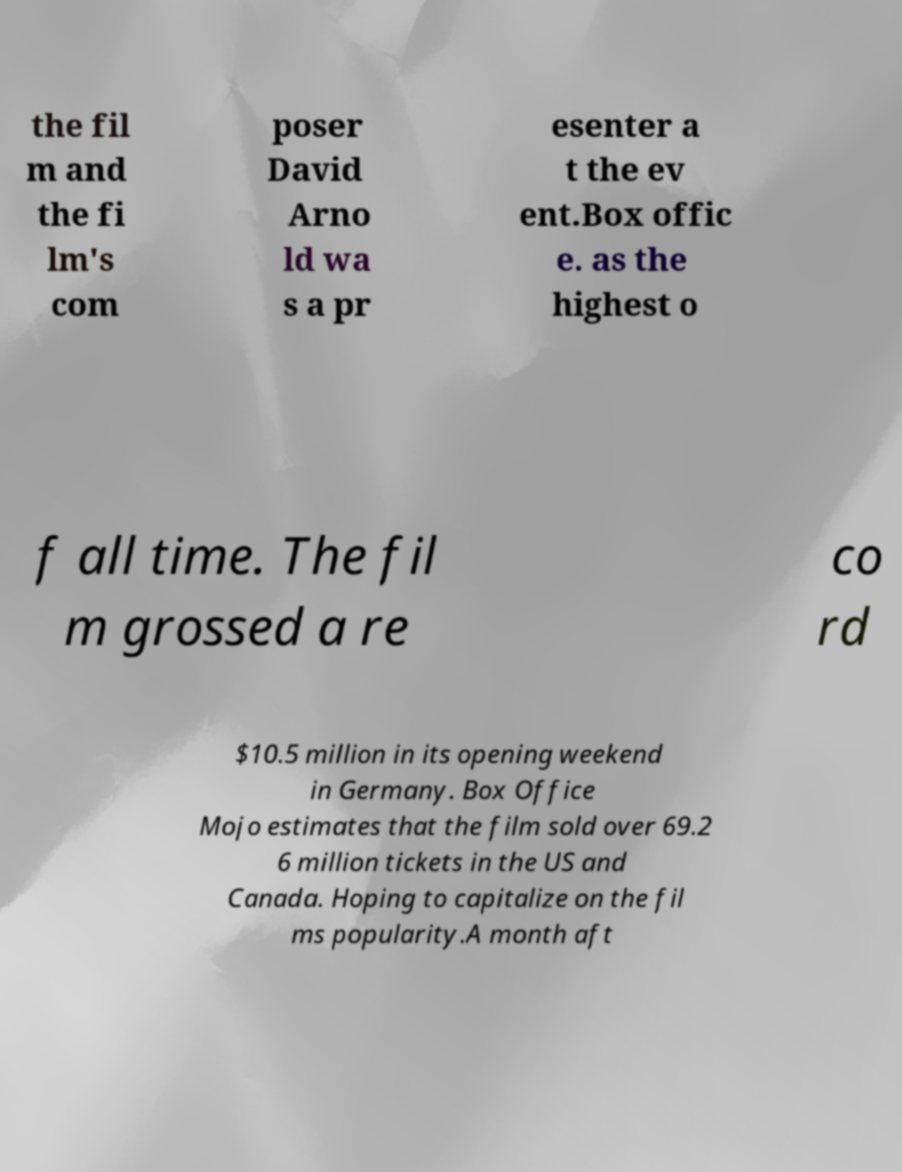There's text embedded in this image that I need extracted. Can you transcribe it verbatim? the fil m and the fi lm's com poser David Arno ld wa s a pr esenter a t the ev ent.Box offic e. as the highest o f all time. The fil m grossed a re co rd $10.5 million in its opening weekend in Germany. Box Office Mojo estimates that the film sold over 69.2 6 million tickets in the US and Canada. Hoping to capitalize on the fil ms popularity.A month aft 